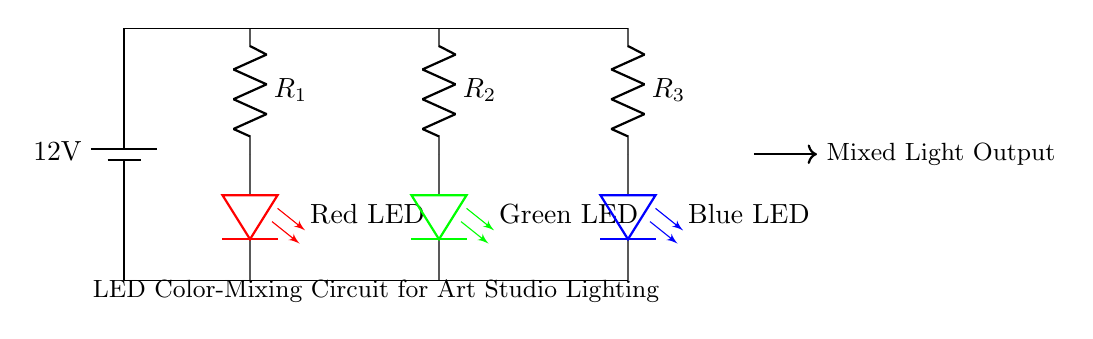What is the power supply voltage? The power supply voltage is indicated next to the battery symbol, which shows a potential difference of 12 volts.
Answer: 12 volts What type of light-emitting diode is used in the circuit? The circuit includes three types of light-emitting diodes, specifically red, green, and blue, each indicated by color next to the symbol for the LED.
Answer: Red, Green, Blue How many resistors are present in the circuit? The circuit has three resistors between the battery and the LEDs, represented by R1, R2, and R3, each connected in series with an LED.
Answer: Three What is the purpose of the resistors in this circuit? The resistors are used to limit the current flowing through the LEDs, preventing them from burning out due to excessive current.
Answer: Limit current What happens to the mixed light output when all LEDs are turned on? When all LEDs are turned on, the mixed light output combines the colors emitted by the red, green, and blue LEDs, resulting in white light.
Answer: Creates white light What is the main function of this circuit? The main function of this circuit is to provide adjustable custom lighting for an art studio by mixing different colors of light from the LEDs.
Answer: Custom lighting 